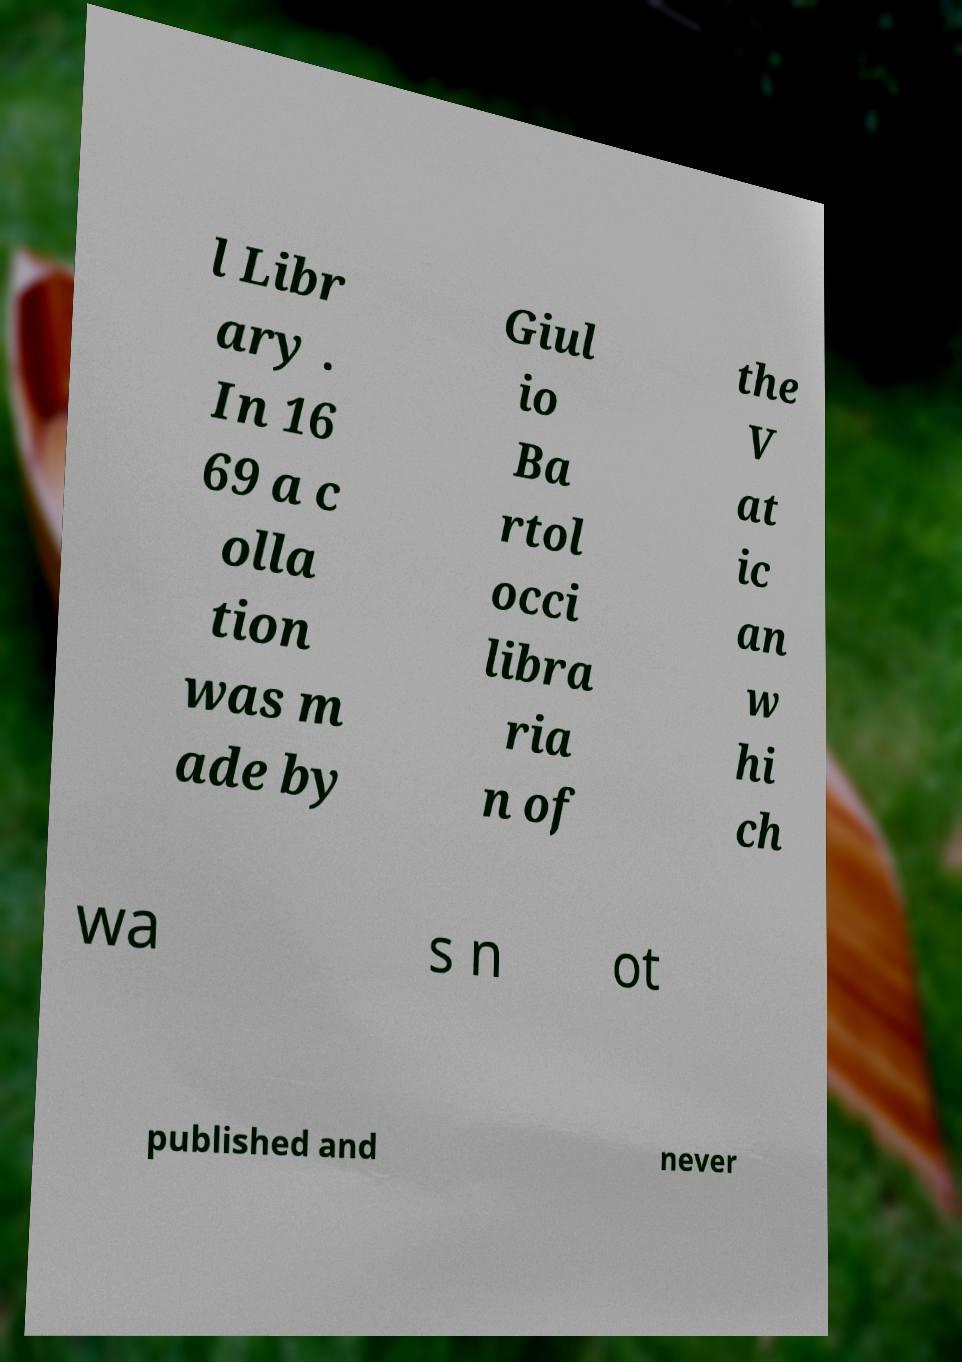Could you assist in decoding the text presented in this image and type it out clearly? l Libr ary . In 16 69 a c olla tion was m ade by Giul io Ba rtol occi libra ria n of the V at ic an w hi ch wa s n ot published and never 